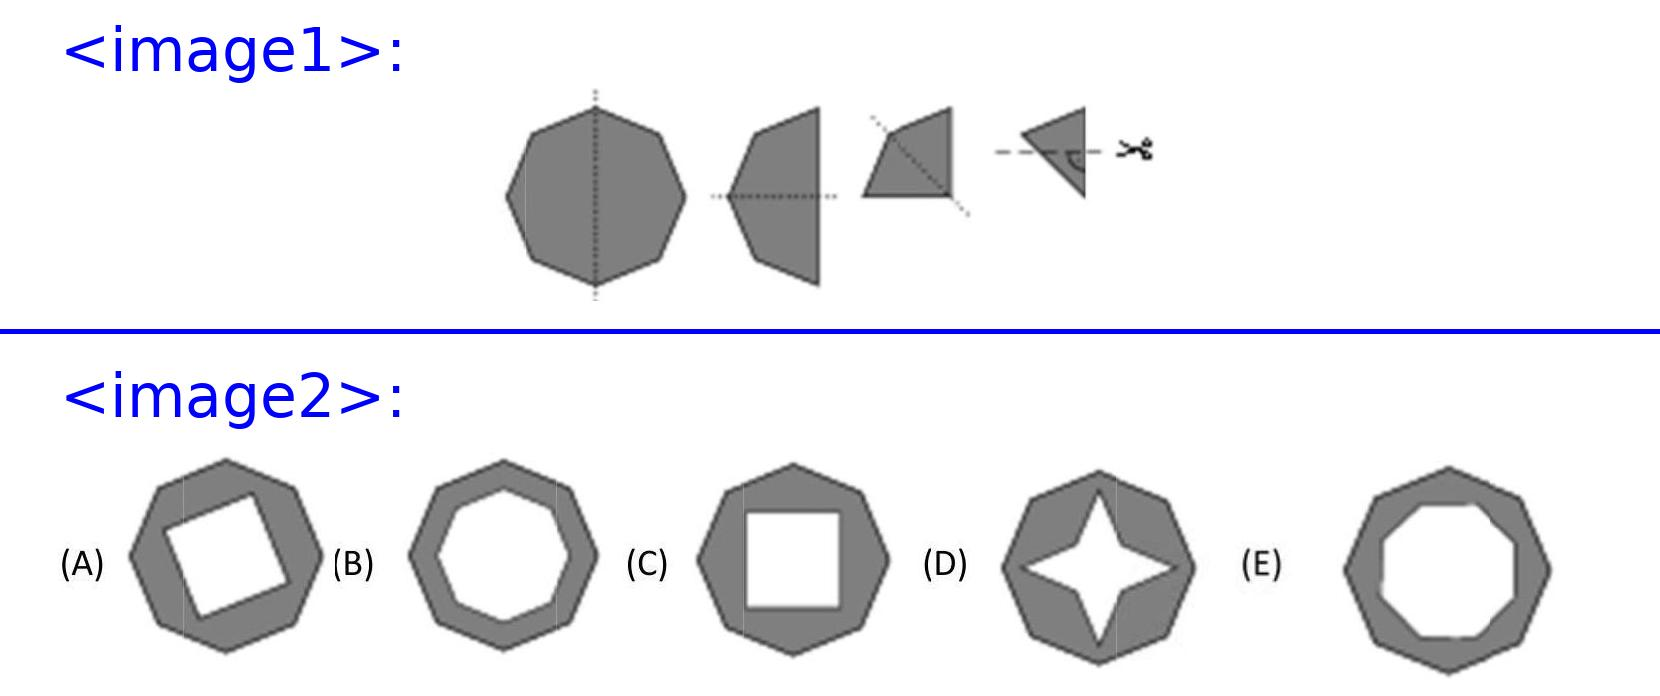Why does choice E not represent the correct shape of the unfolded octagon? Option E shows an octagon where every alternate side is indented uniformly, implying equal cuts on every other vertex. However, the image clearly shows a single cut before folding. This specific cut results in non-uniform shaping when unfolded, as observed in option C. The gaps and shapes of the cuts in E are too systematic and do not correctly represent the asymmetric result of a singular truncated corner being mirrored across all sections. 